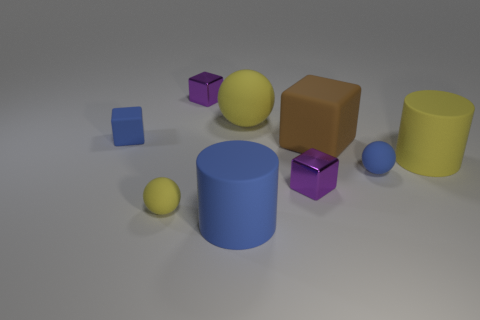The large block has what color?
Offer a terse response. Brown. Does the rubber cylinder that is left of the big yellow rubber cylinder have the same color as the tiny matte object behind the blue rubber ball?
Your answer should be compact. Yes. There is a blue rubber object that is the same shape as the brown thing; what is its size?
Your answer should be very brief. Small. Is there a rubber sphere that has the same color as the big block?
Your answer should be very brief. No. There is another ball that is the same color as the big rubber ball; what is it made of?
Give a very brief answer. Rubber. What number of tiny cubes have the same color as the big ball?
Provide a short and direct response. 0. How many objects are either rubber spheres that are right of the brown rubber cube or large rubber objects?
Provide a short and direct response. 5. There is a small block that is made of the same material as the small blue sphere; what is its color?
Ensure brevity in your answer.  Blue. Is there a shiny block of the same size as the brown matte block?
Make the answer very short. No. What number of things are either blocks in front of the brown block or tiny spheres behind the small yellow matte ball?
Offer a terse response. 2. 